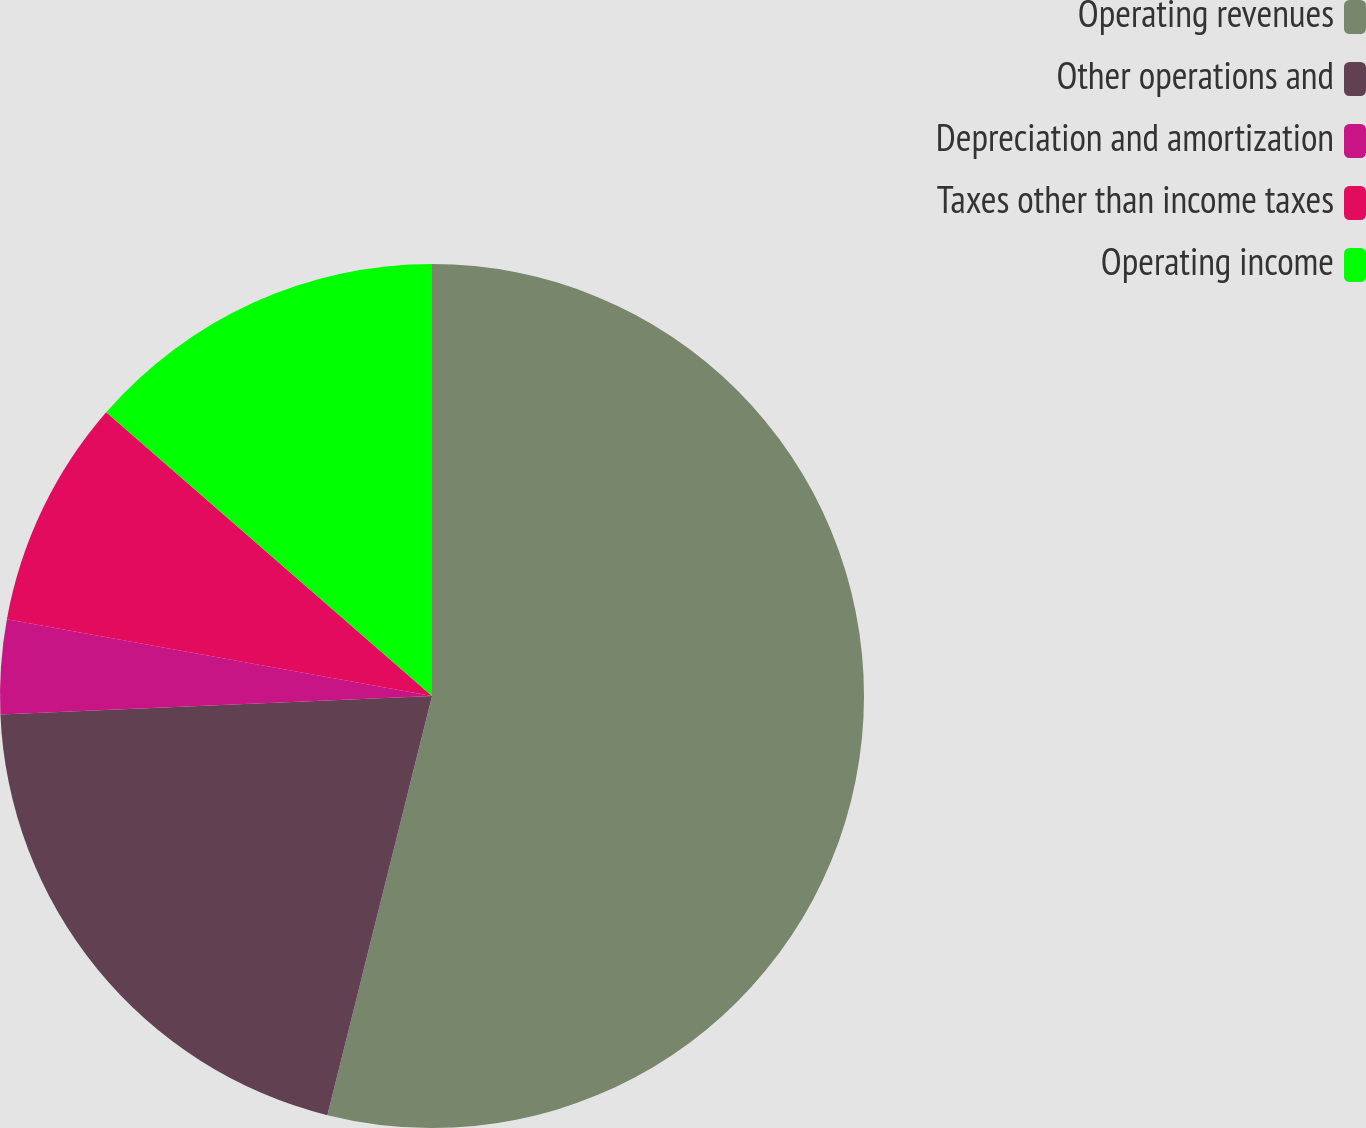<chart> <loc_0><loc_0><loc_500><loc_500><pie_chart><fcel>Operating revenues<fcel>Other operations and<fcel>Depreciation and amortization<fcel>Taxes other than income taxes<fcel>Operating income<nl><fcel>53.9%<fcel>20.43%<fcel>3.52%<fcel>8.56%<fcel>13.6%<nl></chart> 